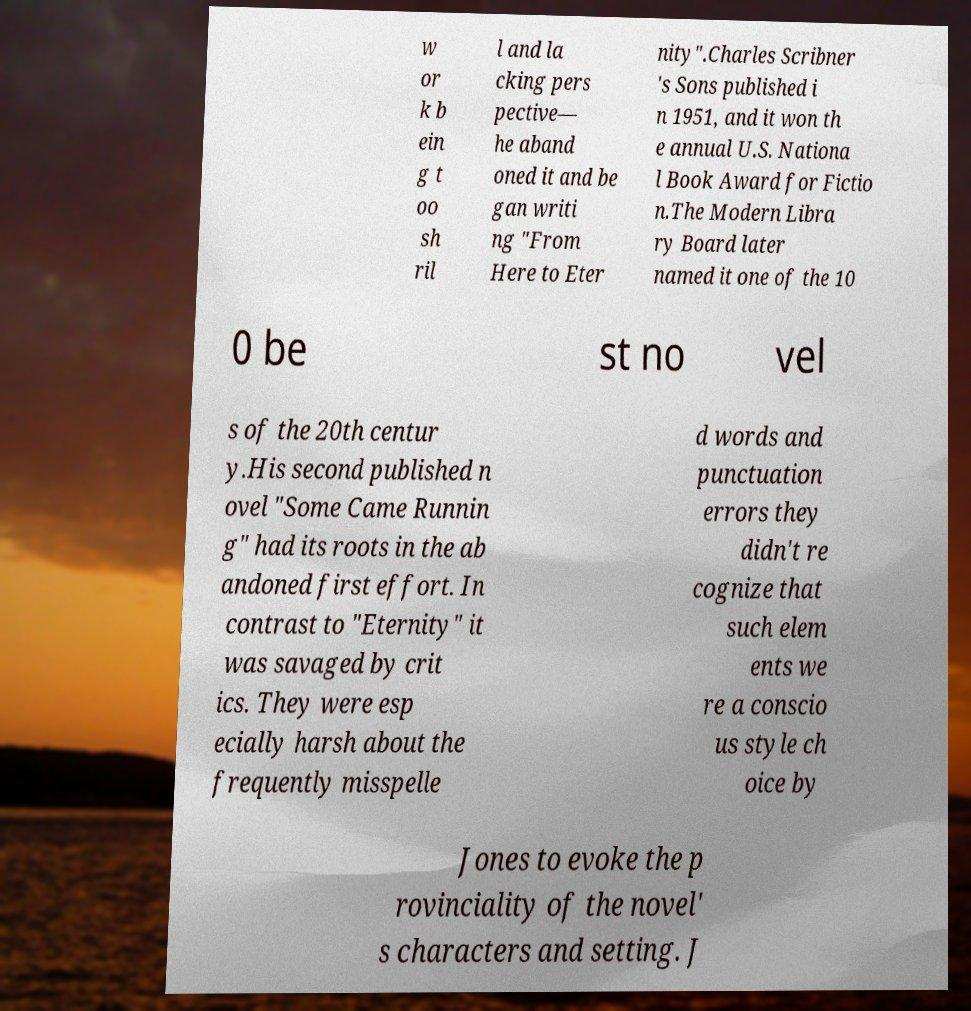Can you read and provide the text displayed in the image?This photo seems to have some interesting text. Can you extract and type it out for me? w or k b ein g t oo sh ril l and la cking pers pective— he aband oned it and be gan writi ng "From Here to Eter nity".Charles Scribner 's Sons published i n 1951, and it won th e annual U.S. Nationa l Book Award for Fictio n.The Modern Libra ry Board later named it one of the 10 0 be st no vel s of the 20th centur y.His second published n ovel "Some Came Runnin g" had its roots in the ab andoned first effort. In contrast to "Eternity" it was savaged by crit ics. They were esp ecially harsh about the frequently misspelle d words and punctuation errors they didn't re cognize that such elem ents we re a conscio us style ch oice by Jones to evoke the p rovinciality of the novel' s characters and setting. J 